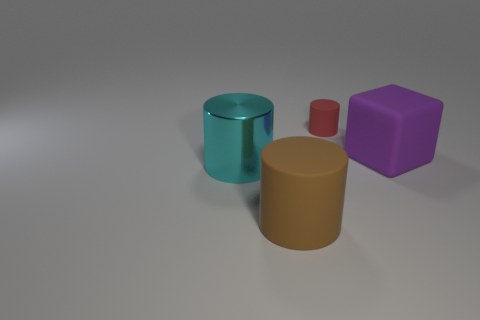There is a big rubber object in front of the cyan thing; what is its shape?
Your answer should be compact. Cylinder. Are there any other large purple objects made of the same material as the big purple thing?
Offer a terse response. No. There is a big cylinder that is in front of the big metallic cylinder; is its color the same as the shiny thing?
Offer a very short reply. No. The metallic cylinder is what size?
Your response must be concise. Large. There is a thing that is in front of the large cylinder that is behind the brown matte object; is there a brown cylinder on the right side of it?
Make the answer very short. No. There is a metallic object; what number of purple rubber cubes are on the right side of it?
Make the answer very short. 1. How many matte cylinders are the same color as the large rubber block?
Ensure brevity in your answer.  0. How many things are objects in front of the cyan thing or rubber cylinders that are on the right side of the brown thing?
Your response must be concise. 2. Are there more yellow matte things than red cylinders?
Your answer should be very brief. No. There is a large matte thing that is left of the tiny matte object; what is its color?
Ensure brevity in your answer.  Brown. 